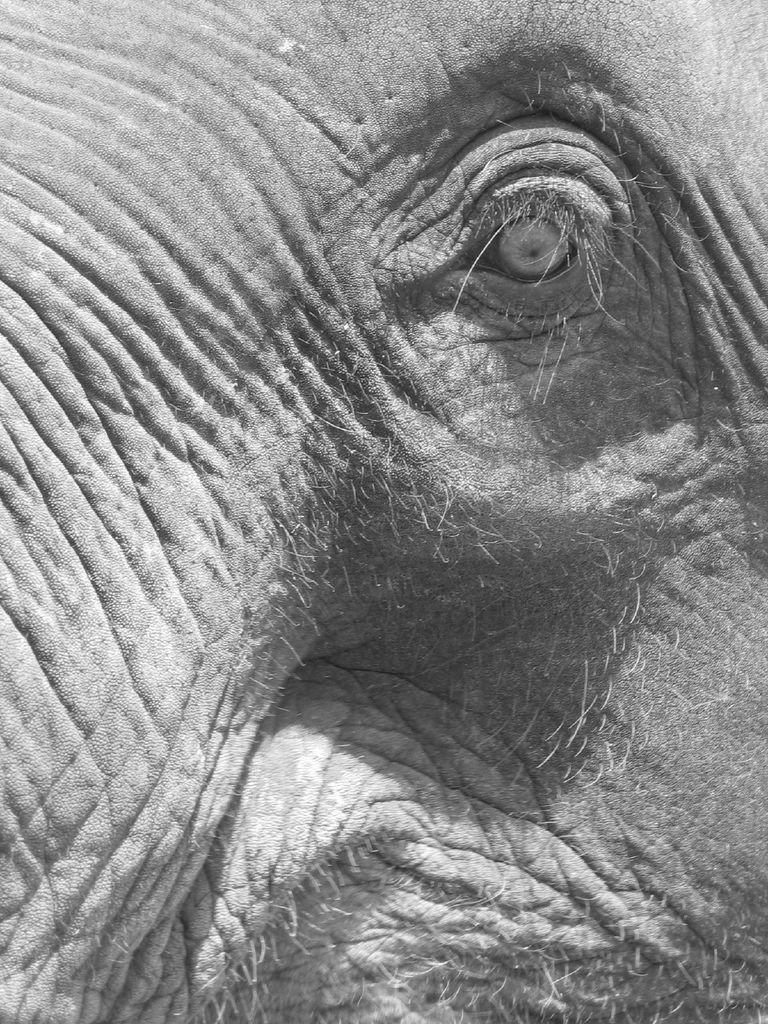What is the color scheme of the image? The image is black and white. What part of an elephant can be seen in the image? There is an elephant's eye in the image. What can be observed on the body of the elephant in the image? There are hairs on the body of the elephant in the image. What type of precipitation is falling in the image? There is no precipitation visible in the image, as it is a black and white image of an elephant's eye. Who is the governor in the image? There is no person or governor present in the image; it features an elephant's eye. 